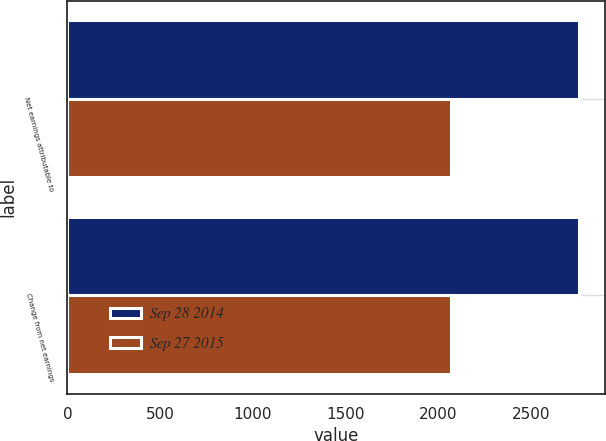Convert chart. <chart><loc_0><loc_0><loc_500><loc_500><stacked_bar_chart><ecel><fcel>Net earnings attributable to<fcel>Change from net earnings<nl><fcel>Sep 28 2014<fcel>2757.4<fcel>2759.1<nl><fcel>Sep 27 2015<fcel>2068.1<fcel>2068.1<nl></chart> 